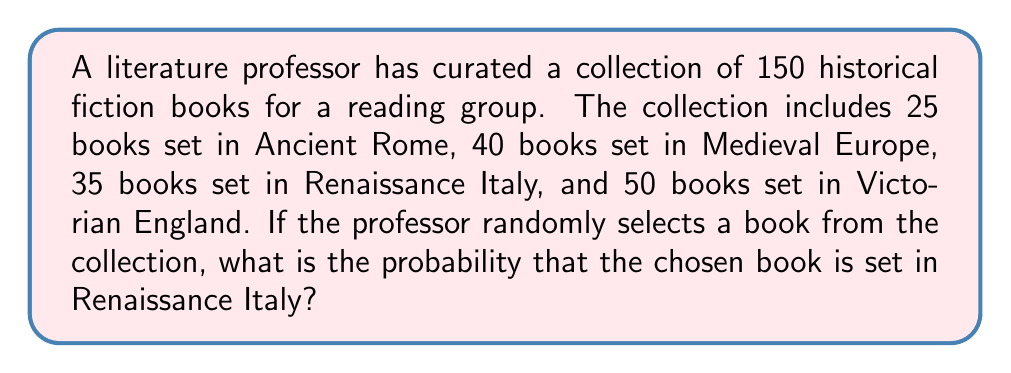Help me with this question. To solve this problem, we need to use the concept of probability in a finite sample space. The probability of an event occurring is the number of favorable outcomes divided by the total number of possible outcomes, given that all outcomes are equally likely.

Let's break down the given information:
1. Total number of books in the collection: 150
2. Number of books set in Renaissance Italy: 35

To calculate the probability, we use the formula:

$$ P(\text{Renaissance Italy}) = \frac{\text{Number of favorable outcomes}}{\text{Total number of possible outcomes}} $$

Substituting the values:

$$ P(\text{Renaissance Italy}) = \frac{35}{150} $$

To simplify this fraction, we can divide both the numerator and denominator by their greatest common divisor (GCD). The GCD of 35 and 150 is 5.

$$ P(\text{Renaissance Italy}) = \frac{35 \div 5}{150 \div 5} = \frac{7}{30} $$

Therefore, the probability of randomly selecting a book set in Renaissance Italy from the curated collection is $\frac{7}{30}$.
Answer: $\frac{7}{30}$ 